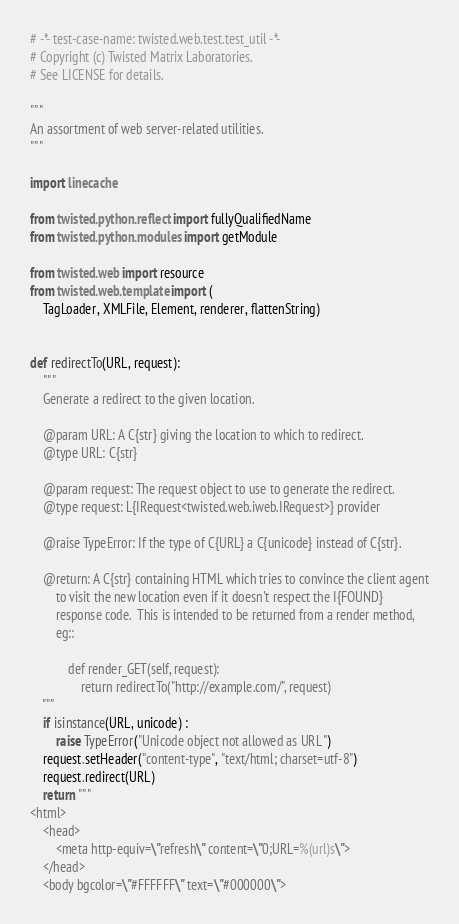Convert code to text. <code><loc_0><loc_0><loc_500><loc_500><_Python_># -*- test-case-name: twisted.web.test.test_util -*-
# Copyright (c) Twisted Matrix Laboratories.
# See LICENSE for details.

"""
An assortment of web server-related utilities.
"""

import linecache

from twisted.python.reflect import fullyQualifiedName
from twisted.python.modules import getModule

from twisted.web import resource
from twisted.web.template import (
    TagLoader, XMLFile, Element, renderer, flattenString)


def redirectTo(URL, request):
    """
    Generate a redirect to the given location.

    @param URL: A C{str} giving the location to which to redirect.
    @type URL: C{str}

    @param request: The request object to use to generate the redirect.
    @type request: L{IRequest<twisted.web.iweb.IRequest>} provider

    @raise TypeError: If the type of C{URL} a C{unicode} instead of C{str}.

    @return: A C{str} containing HTML which tries to convince the client agent
        to visit the new location even if it doesn't respect the I{FOUND}
        response code.  This is intended to be returned from a render method,
        eg::

            def render_GET(self, request):
                return redirectTo("http://example.com/", request)
    """
    if isinstance(URL, unicode) :
        raise TypeError("Unicode object not allowed as URL")
    request.setHeader("content-type", "text/html; charset=utf-8")
    request.redirect(URL)
    return """
<html>
    <head>
        <meta http-equiv=\"refresh\" content=\"0;URL=%(url)s\">
    </head>
    <body bgcolor=\"#FFFFFF\" text=\"#000000\"></code> 